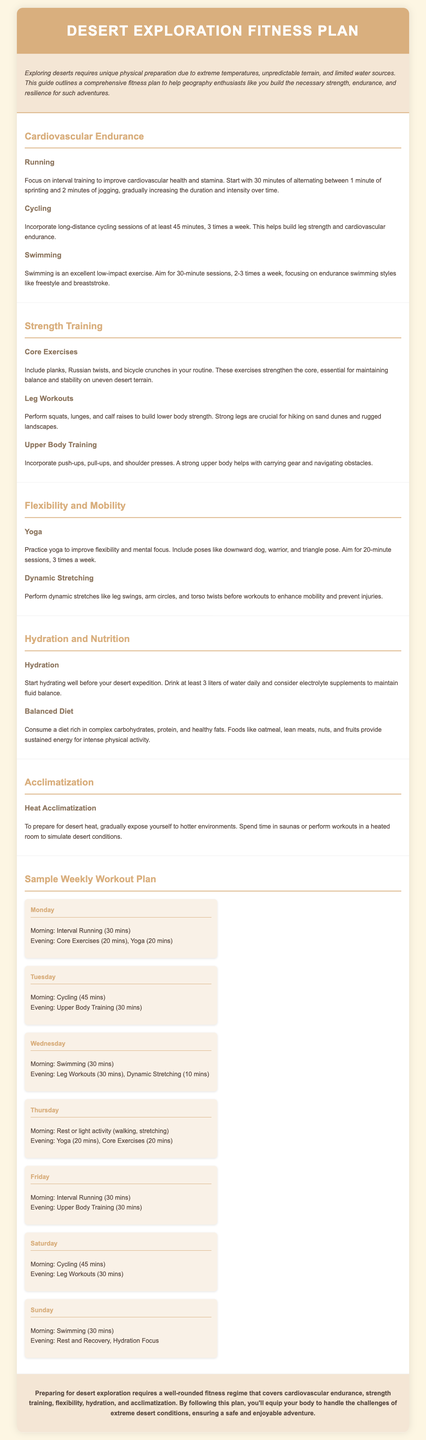What is the primary focus of the fitness plan? The fitness plan focuses on preparing the body for extreme desert conditions through various workouts and activities.
Answer: Preparing the body for extreme desert conditions How many liters of water should you drink daily before desert exploration? The document states that one should drink at least 3 liters of water daily before the expedition.
Answer: 3 liters What type of training is suggested for cardiovascular endurance? The document suggests interval training as a method to improve cardiovascular endurance.
Answer: Interval training How often should yoga sessions be performed? The plan recommends practicing yoga sessions 3 times a week to improve flexibility and mental focus.
Answer: 3 times a week What are two examples of core exercises? The document lists planks and Russian twists as examples of core exercises.
Answer: Planks, Russian twists How many minutes is the suggested duration for one swimming session? The plan states that swimming sessions should last for 30 minutes.
Answer: 30 minutes What type of nutrition is emphasized in the plan? The document emphasizes a balanced diet rich in complex carbohydrates, protein, and healthy fats.
Answer: Balanced diet On which day is rest or light activity recommended? The document suggests rest or light activity on Thursday.
Answer: Thursday What is the purpose of heat acclimatization? Heat acclimatization is meant to prepare the body for desert heat by gradually exposing it to hotter environments.
Answer: Prepare the body for desert heat 